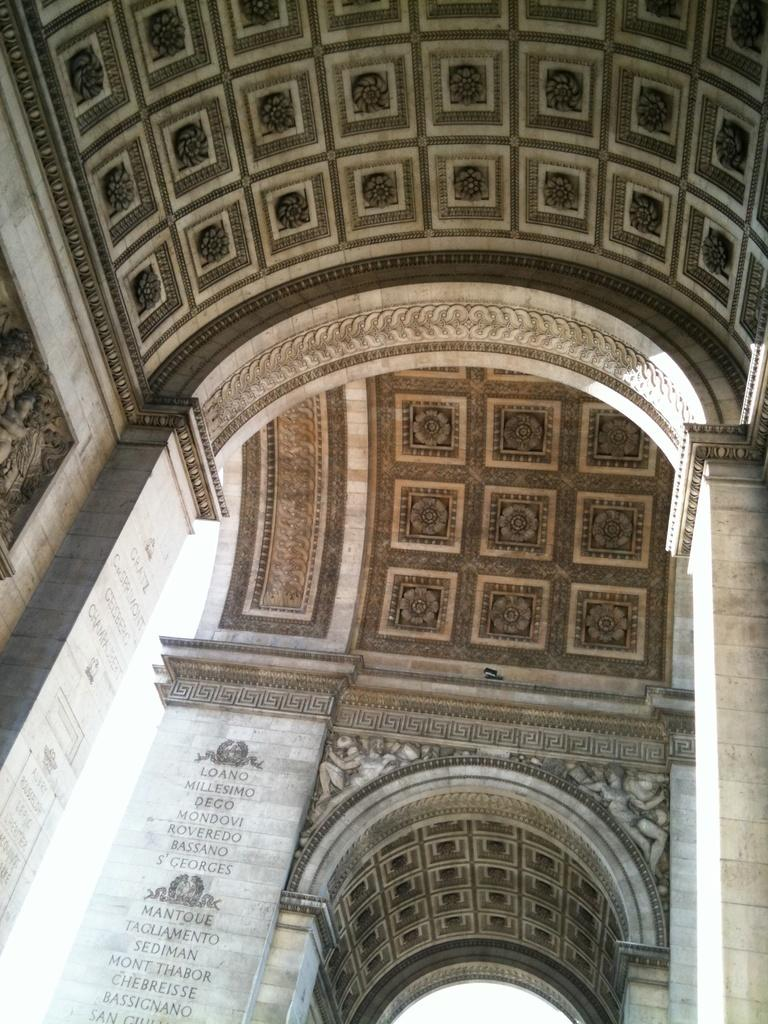What architectural features can be seen in the image? There are arches and pillars in the image. What can be found on the ceiling in the image? There are designs on the ceiling in the image. What is written on the pillars in the image? There is writing on the pillars in the image. What type of artwork is present on the wall in the image? There are sculptures on the wall in the image. What type of polish is used to maintain the arches in the image? There is no information about polish or maintenance in the image; it only shows the arches and other architectural features. 